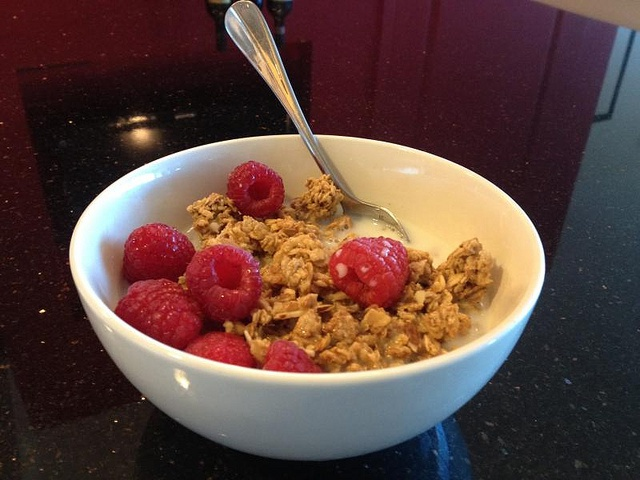Describe the objects in this image and their specific colors. I can see bowl in maroon, tan, and brown tones, dining table in maroon, black, blue, and navy tones, and spoon in maroon, gray, tan, and darkgray tones in this image. 